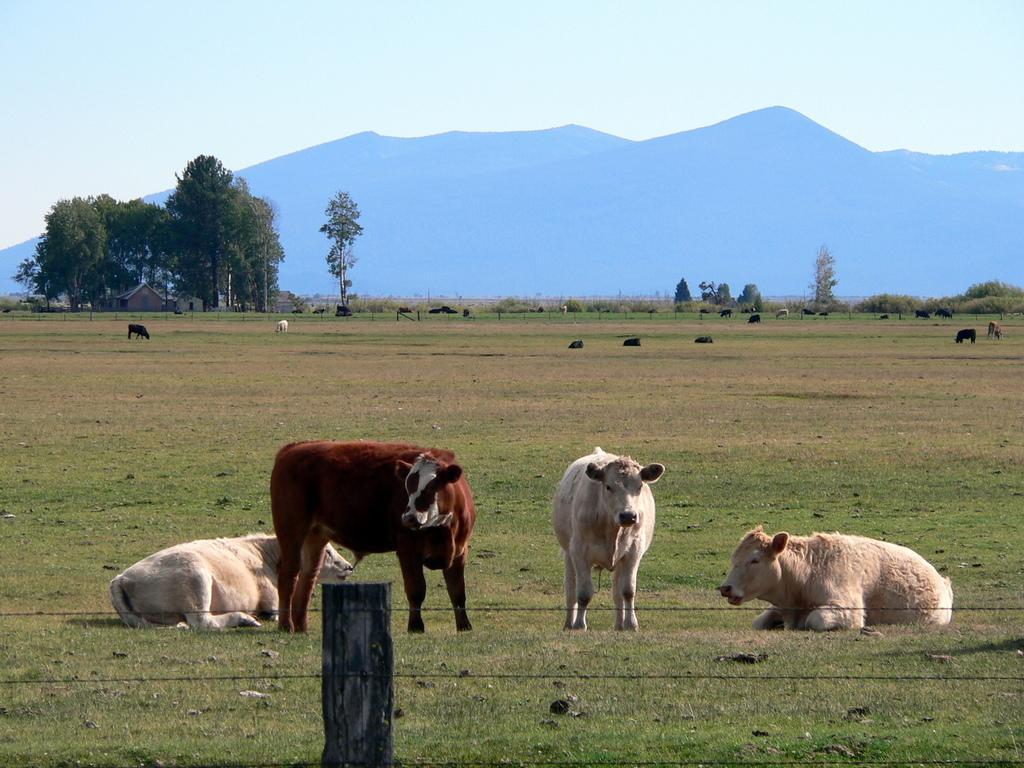Describe this image in one or two sentences. In this image we can see cows. On the ground there is grass. And there is a fencing with a wooden pole. In the background there are trees. Also there are hills and sky. And there are few houses in the background. 